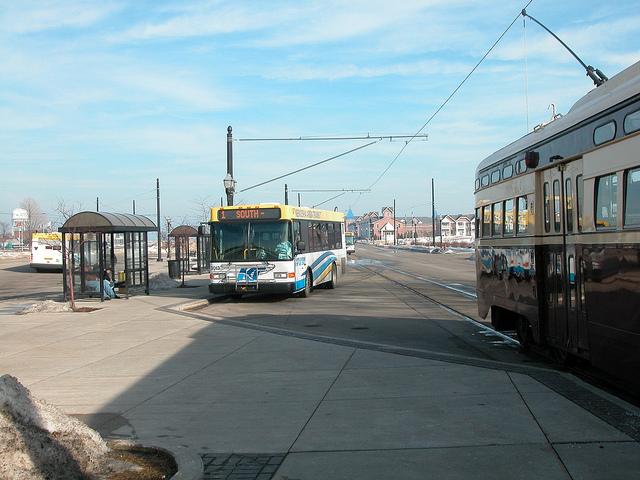What color is the bus on the right?
Keep it brief. Yellow. What color is the snow?
Answer briefly. White. Would you consider this to be an urban area?
Be succinct. Yes. What are the people waiting for?
Quick response, please. Bus. 